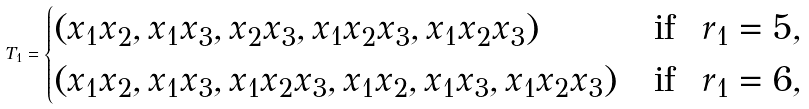Convert formula to latex. <formula><loc_0><loc_0><loc_500><loc_500>T _ { 1 } = \begin{cases} \left ( x _ { 1 } x _ { 2 } , x _ { 1 } x _ { 3 } , x _ { 2 } x _ { 3 } , x _ { 1 } x _ { 2 } x _ { 3 } , x _ { 1 } x _ { 2 } x _ { 3 } \right ) & \text {if \ $r_{1}=5$} , \\ \left ( x _ { 1 } x _ { 2 } , x _ { 1 } x _ { 3 } , x _ { 1 } x _ { 2 } x _ { 3 } , x _ { 1 } x _ { 2 } , x _ { 1 } x _ { 3 } , x _ { 1 } x _ { 2 } x _ { 3 } \right ) & \text {if \ $r_{1}=6$} , \end{cases}</formula> 